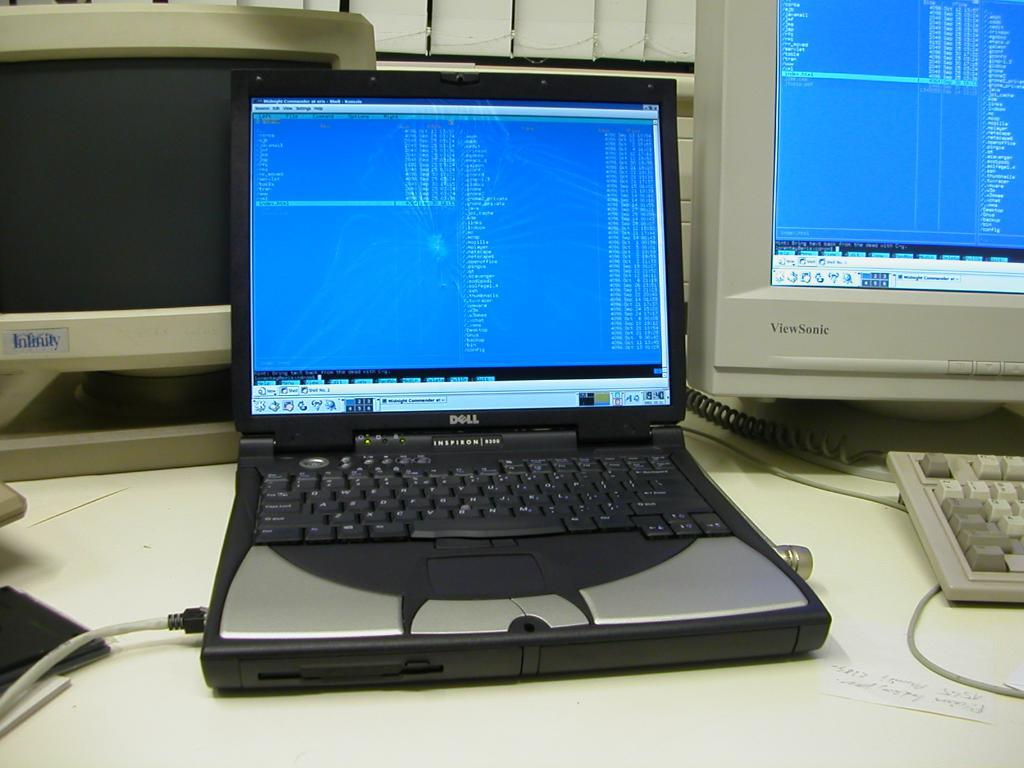<image>
Provide a brief description of the given image. The lap top sitting on the desk with other workstations was made by Dell. 